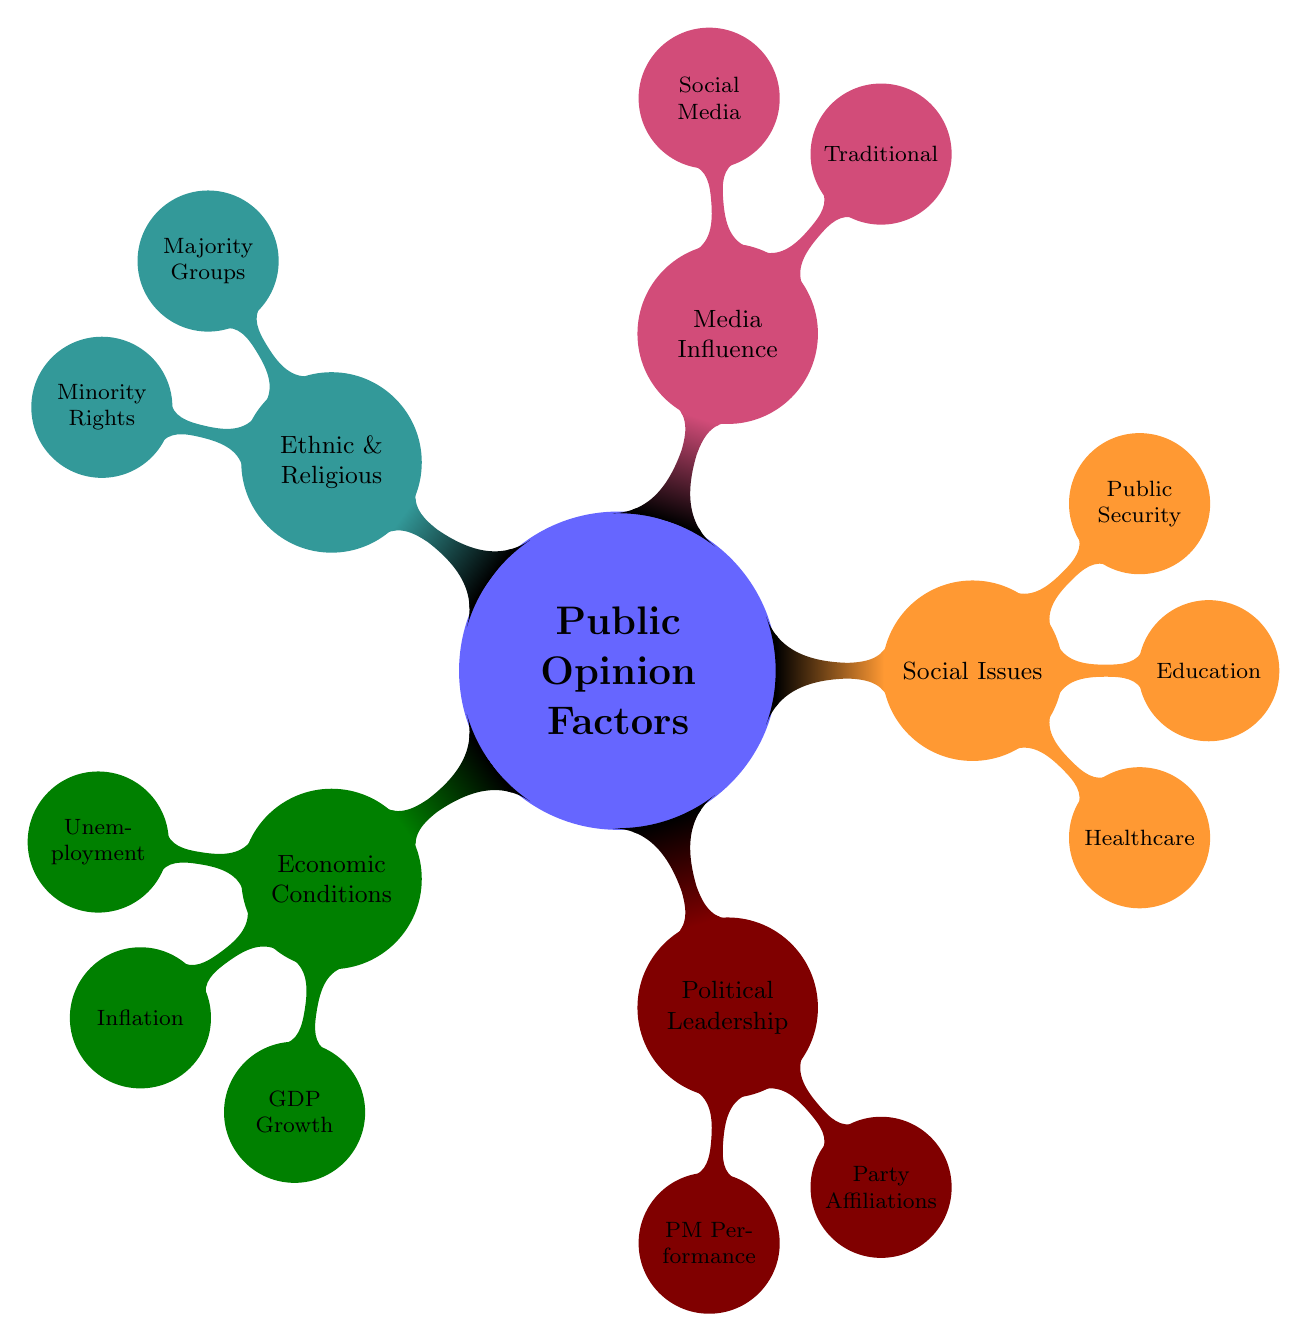What are the main categories of public opinion factors influencing elections? The mind map has five main categories branching from the central theme "Public Opinion Factors," which are Economic Conditions, Political Leadership, Social Issues, Media Influence, and Ethnic & Religious Factors.
Answer: Economic Conditions, Political Leadership, Social Issues, Media Influence, Ethnic & Religious Factors How many nodes are there under "Economic Conditions"? Under the "Economic Conditions" node, there are three sub-nodes: Unemployment Rate, Inflation, and GDP Growth. Thus, the total number of nodes is three.
Answer: 3 Which political leaders are mentioned in the diagram? The mind map identifies two political leaders under the "Prime Minister Performance" sub-node: Prayuth Chan-o-cha and Anwar Ibrahim. Thus, the answer includes their names.
Answer: Prayuth Chan-o-cha, Anwar Ibrahim What type of media is represented in the "Media Influence" category? The "Media Influence" node is divided into two sub-categories—Traditional Media and Social Media. Each of these categories further branches into specific types, such as Television and Newspapers for Traditional Media, and Facebook and Twitter for Social Media.
Answer: Traditional Media, Social Media Which party affiliations are listed under "Political Leadership"? The "Party Affiliations" node includes two specific parties: Pheu Thai Party and United Malays National Organisation (UMNO). Therefore, the answer includes the names of both parties.
Answer: Pheu Thai Party, United Malays National Organisation (UMNO) What are the sub-issues addressed under "Social Issues"? The "Social Issues" node branches out to three specific sub-issues indicated in the diagram: Healthcare, Education, and Public Security. Thus, these are the sub-issues represented.
Answer: Healthcare, Education, Public Security How do ethnic and religious factors relate to the majority groups in the countries? The "Ethnic & Religious Factors" node includes specific references to the Majority Groups in both countries: Malay-Muslim Majority in Malaysia and Thai-Buddhist Majority in Thailand. It shows the context of how these groups influence public opinion.
Answer: Malay-Muslim Majority, Thai-Buddhist Majority Are there more aspects related to public security or inflation discussed in the diagram? Within the mind map, "Public Security" is part of the "Social Issues" category, while "Inflation" is under "Economic Conditions." Each category has just one node related to these aspects, making it a comparison of equal count.
Answer: Equal What are the two main types of media discussed? The diagram specifies two types of media under "Media Influence": Traditional Media and Social Media. This clearly identifies the two significant categories of media.
Answer: Traditional Media, Social Media 